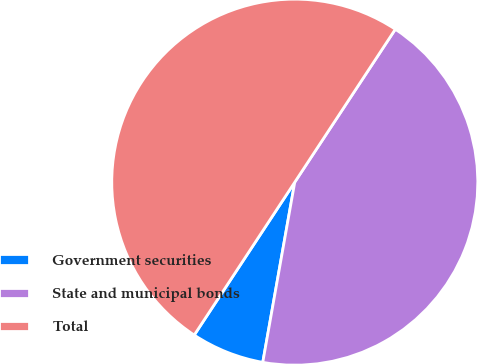Convert chart. <chart><loc_0><loc_0><loc_500><loc_500><pie_chart><fcel>Government securities<fcel>State and municipal bonds<fcel>Total<nl><fcel>6.46%<fcel>43.54%<fcel>50.0%<nl></chart> 